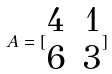Convert formula to latex. <formula><loc_0><loc_0><loc_500><loc_500>A = [ \begin{matrix} 4 & 1 \\ 6 & 3 \end{matrix} ]</formula> 